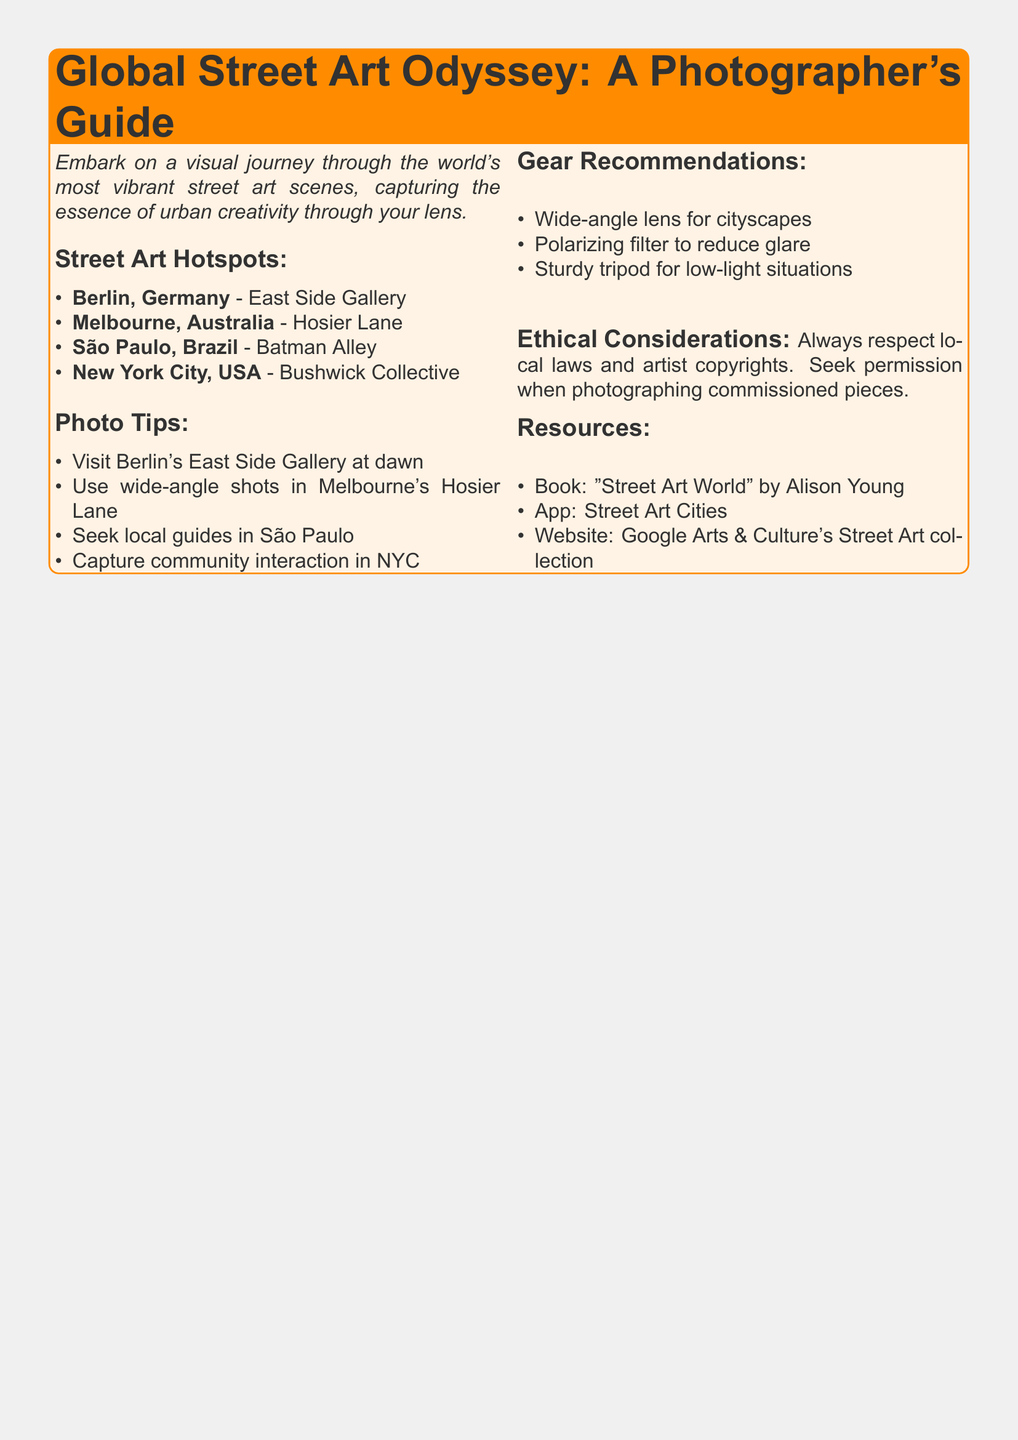What is the title of the guide? The title is presented prominently at the top of the document.
Answer: Global Street Art Odyssey: A Photographer's Guide How many street art hotspots are listed? The document explicitly mentions the number of hotspots in the section title.
Answer: Four Which city is home to the East Side Gallery? The name of the specific city is provided alongside the hotspot's name.
Answer: Berlin What type of lens is recommended for cityscapes? The document lists recommended gear, highlighting specific use cases, including this one.
Answer: Wide-angle lens In which city should you seek local guides according to the photo tips? The document includes city-specific advice that directs the reader to seek assistance in this location.
Answer: São Paulo What is one ethical consideration mentioned? The document notes ethical considerations regarding photography practices, specifically addressing respect for artists.
Answer: Seek permission Which book is recommended as a resource? A specific book title is provided as part of the resources section of the document.
Answer: Street Art World What type of shots should you take in Hosier Lane? The document provides specific photography techniques to improve image quality in specific locations.
Answer: Wide-angle shots What organization is suggested for street art information? The resources section lists specific online collections for further exploration of street art.
Answer: Google Arts & Culture's Street Art collection 